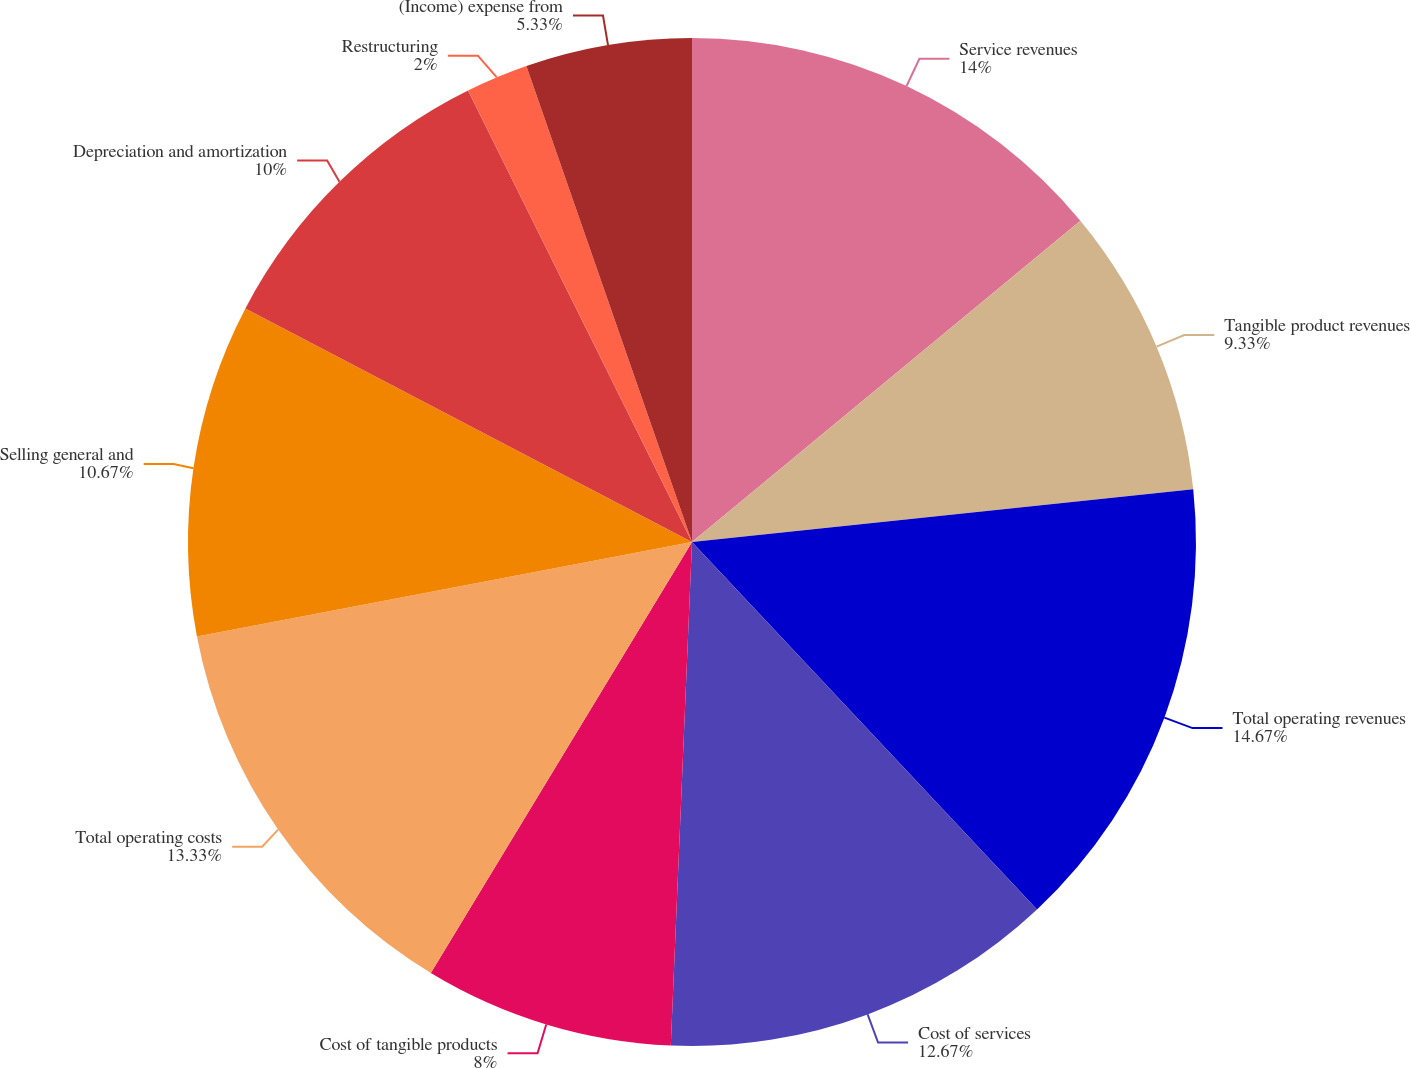Convert chart to OTSL. <chart><loc_0><loc_0><loc_500><loc_500><pie_chart><fcel>Service revenues<fcel>Tangible product revenues<fcel>Total operating revenues<fcel>Cost of services<fcel>Cost of tangible products<fcel>Total operating costs<fcel>Selling general and<fcel>Depreciation and amortization<fcel>Restructuring<fcel>(Income) expense from<nl><fcel>14.0%<fcel>9.33%<fcel>14.67%<fcel>12.67%<fcel>8.0%<fcel>13.33%<fcel>10.67%<fcel>10.0%<fcel>2.0%<fcel>5.33%<nl></chart> 